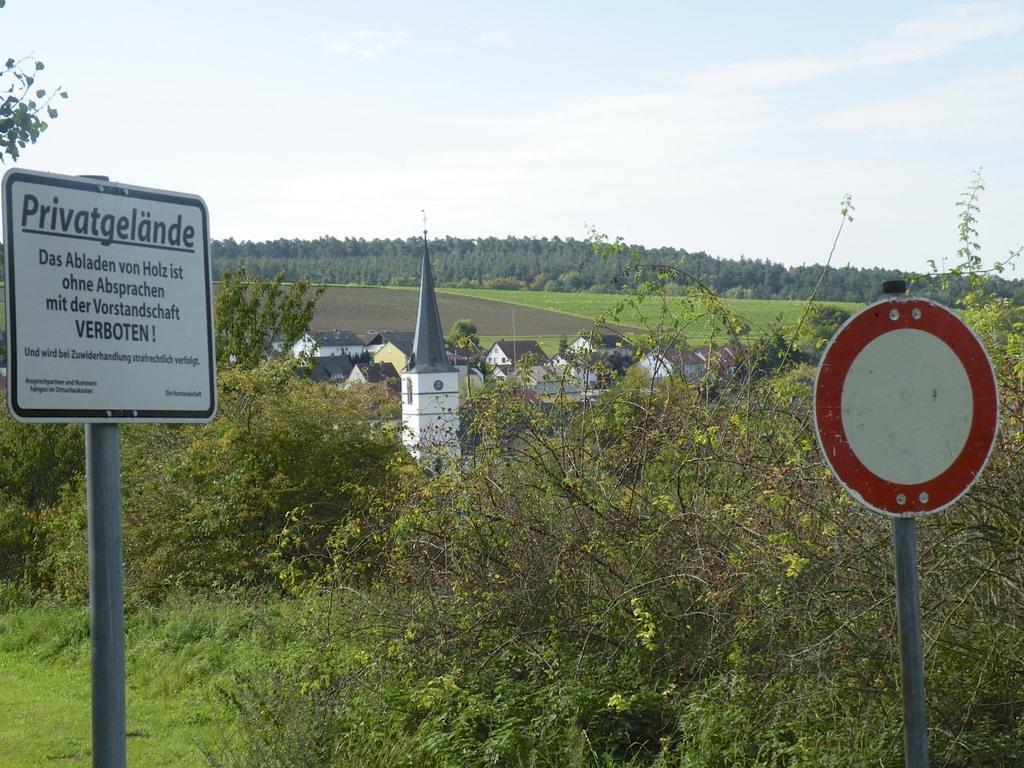How would you summarize this image in a sentence or two? In this picture we can see some text, boards and some grass on the ground. We can see a few plants, houses and some greenery in the background. There is the sky and the clouds visible on top. 